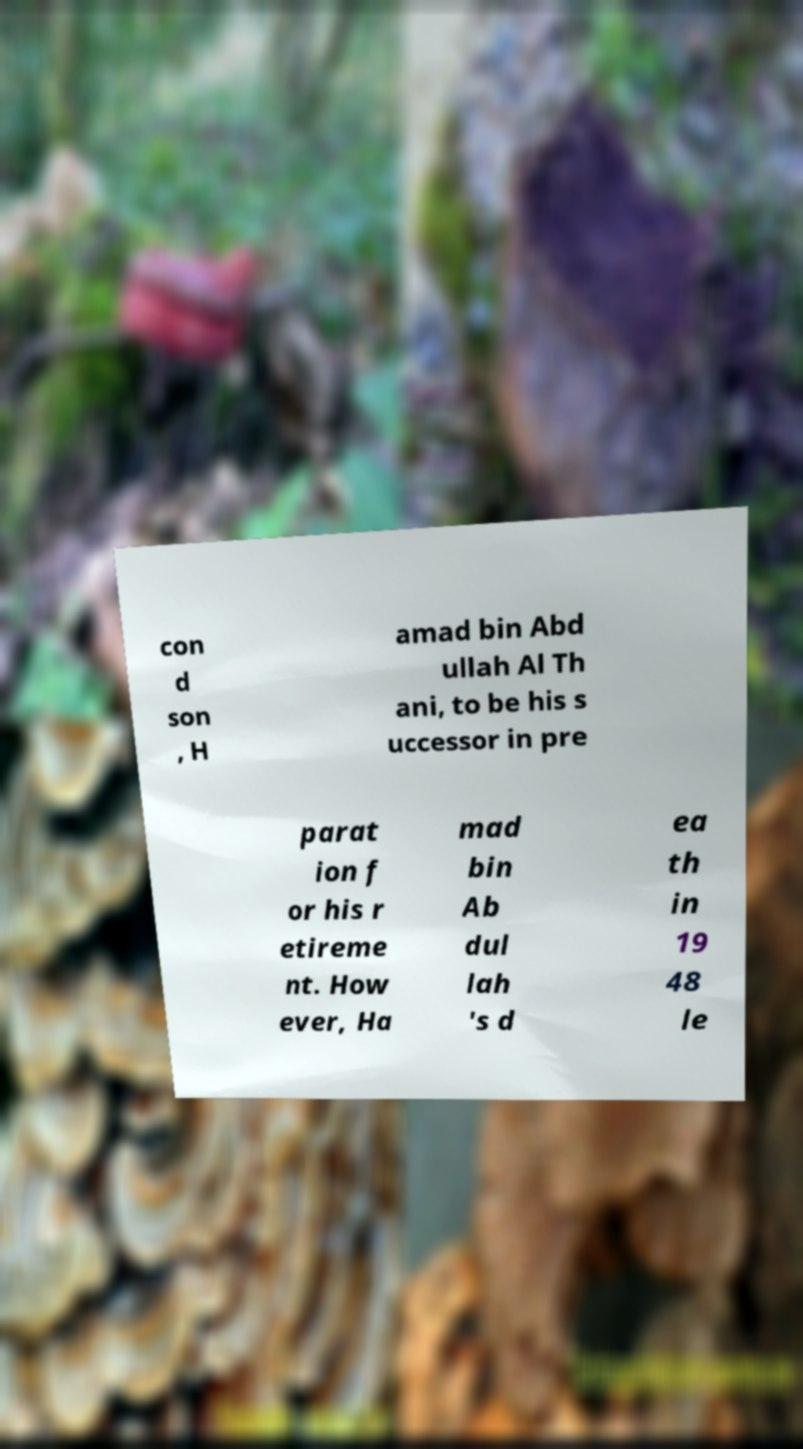What messages or text are displayed in this image? I need them in a readable, typed format. con d son , H amad bin Abd ullah Al Th ani, to be his s uccessor in pre parat ion f or his r etireme nt. How ever, Ha mad bin Ab dul lah 's d ea th in 19 48 le 